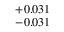<formula> <loc_0><loc_0><loc_500><loc_500>^ { + 0 . 0 3 1 } _ { - 0 . 0 3 1 }</formula> 